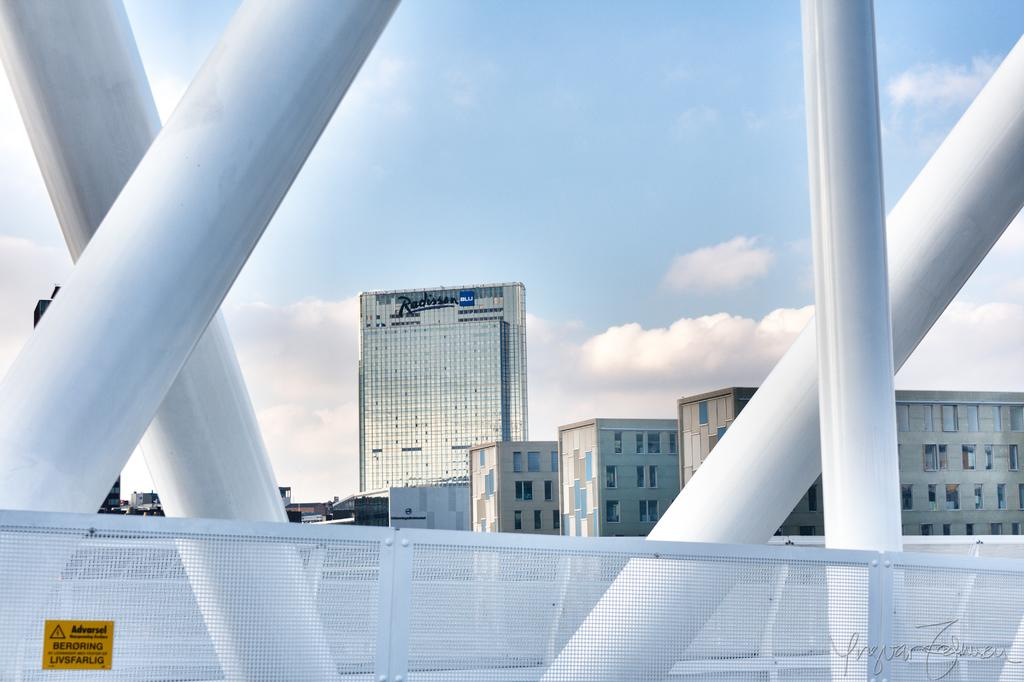<image>
Create a compact narrative representing the image presented. A fence on a bridge with a sticker giving an Adversel 